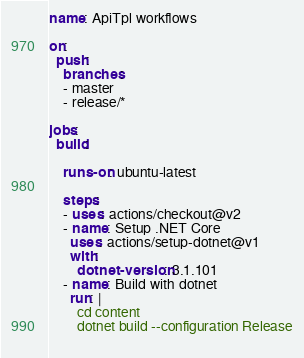<code> <loc_0><loc_0><loc_500><loc_500><_YAML_>name: ApiTpl workflows

on:
  push:
    branches:
    - master
    - release/*

jobs:
  build:

    runs-on: ubuntu-latest

    steps:
    - uses: actions/checkout@v2
    - name: Setup .NET Core
      uses: actions/setup-dotnet@v1
      with:
        dotnet-version: 3.1.101
    - name: Build with dotnet
      run: |
        cd content
        dotnet build --configuration Release
             
</code> 